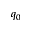Convert formula to latex. <formula><loc_0><loc_0><loc_500><loc_500>q _ { 0 }</formula> 